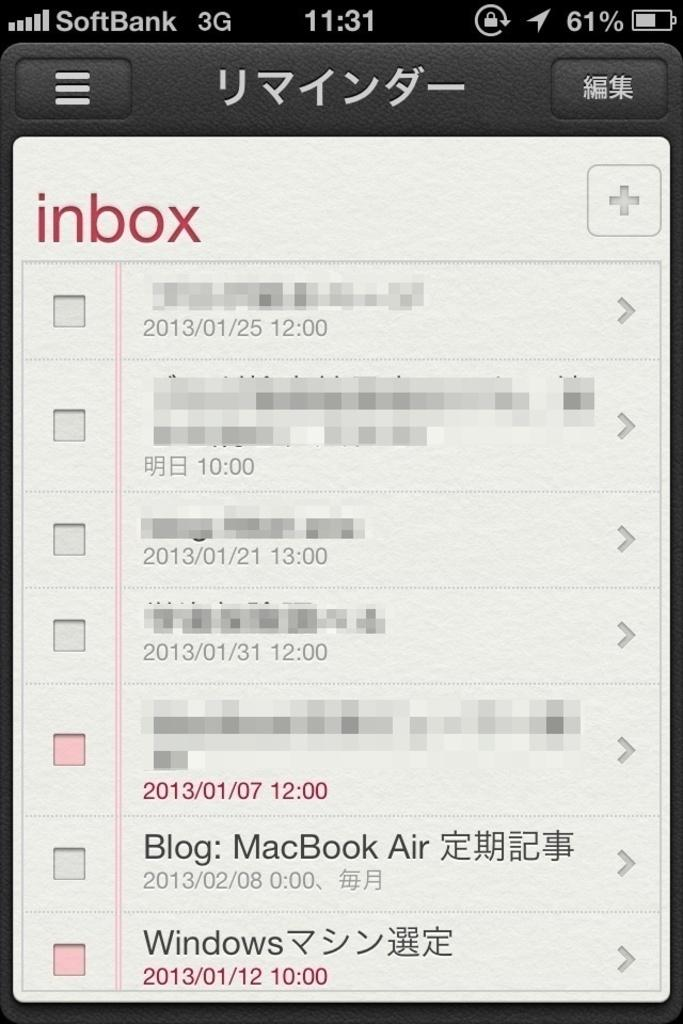<image>
Create a compact narrative representing the image presented. A screen showing somebodies inbox in Japanese language 